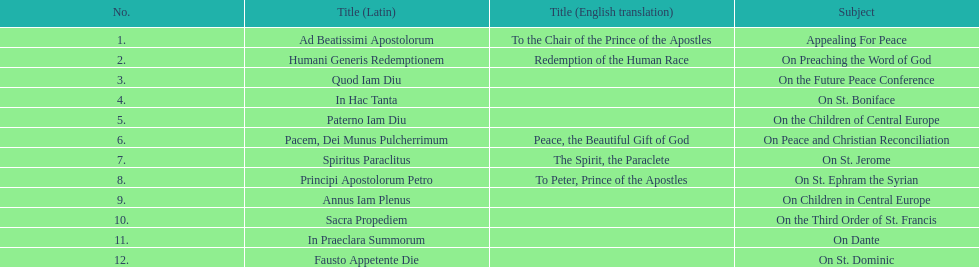What is the subject listed after appealing for peace? On Preaching the Word of God. 